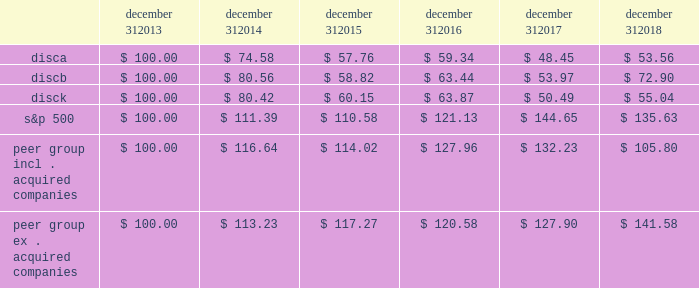Stock performance graph the following graph sets forth the cumulative total shareholder return on our series a common stock , series b common stock and series c common stock as compared with the cumulative total return of the companies listed in the standard and poor 2019s 500 stock index ( 201cs&p 500 index 201d ) and a peer group of companies comprised of cbs corporation class b common stock , scripps network interactive , inc .
( acquired by the company in march 2018 ) , time warner , inc .
( acquired by at&t inc .
In june 2018 ) , twenty-first century fox , inc .
Class a common stock ( news corporation class a common stock prior to june 2013 ) , viacom , inc .
Class b common stock and the walt disney company .
The graph assumes $ 100 originally invested on december 31 , 2013 in each of our series a common stock , series b common stock and series c common stock , the s&p 500 index , and the stock of our peer group companies , including reinvestment of dividends , for the years ended december 31 , 2014 , 2015 , 2016 , 2017 and 2018 .
Two peer companies , scripps networks interactive , inc .
And time warner , inc. , were acquired in 2018 .
The stock performance chart shows the peer group including scripps networks interactive , inc .
And time warner , inc .
And excluding both acquired companies for the entire five year period .
December 31 , december 31 , december 31 , december 31 , december 31 , december 31 .
Equity compensation plan information information regarding securities authorized for issuance under equity compensation plans will be set forth in our definitive proxy statement for our 2019 annual meeting of stockholders under the caption 201csecurities authorized for issuance under equity compensation plans , 201d which is incorporated herein by reference. .
Did the k series 5 year total return outperform the s&p 500? 
Computations: (55.04 > 135.63)
Answer: no. 